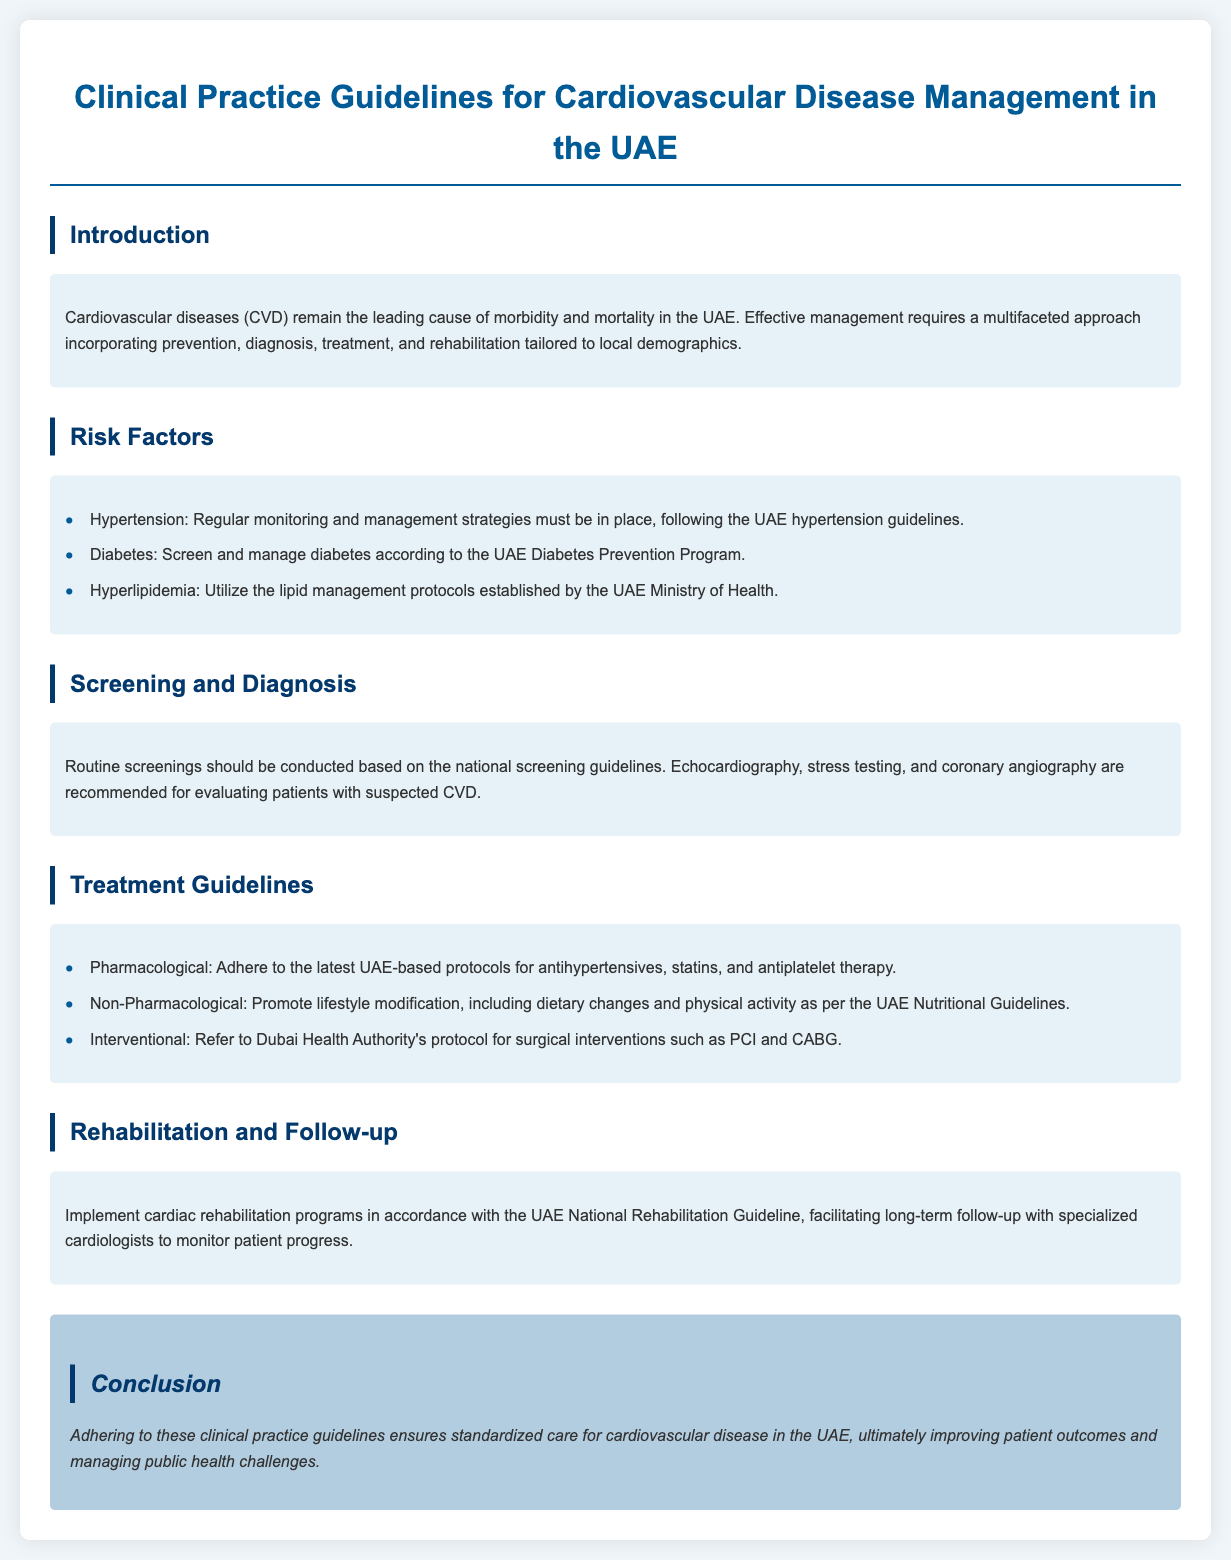What is the title of the guidelines? The title of the guidelines is explicitly stated at the beginning of the document.
Answer: Clinical Practice Guidelines for Cardiovascular Disease Management in the UAE What is the leading cause of morbidity in the UAE? The document mentions a specific condition that is the leading cause of morbidity.
Answer: Cardiovascular diseases Which risk factor requires screening and management according to the UAE Diabetes Prevention Program? One of the listed risk factors directly references the need for a specific program.
Answer: Diabetes What diagnostic test is recommended for evaluating suspected CVD? The document lists a specific test that is advised for this evaluation.
Answer: Echocardiography What does the UAE nutritional guideline promote for non-pharmacological treatment? The document specifies what type of changes are encouraged in the non-pharmacological section.
Answer: Lifestyle modification Which authority's protocol should be referred for surgical interventions? The document cites a specific authority relevant to surgical procedures.
Answer: Dubai Health Authority What should be implemented according to the UAE National Rehabilitation Guideline? The document discusses a specific program relevant to rehabilitation.
Answer: Cardiac rehabilitation programs What kind of follow-up is suggested for monitoring patient progress? The document specifies the type of professional recommended for follow-up.
Answer: Specialized cardiologists 